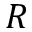Convert formula to latex. <formula><loc_0><loc_0><loc_500><loc_500>R</formula> 